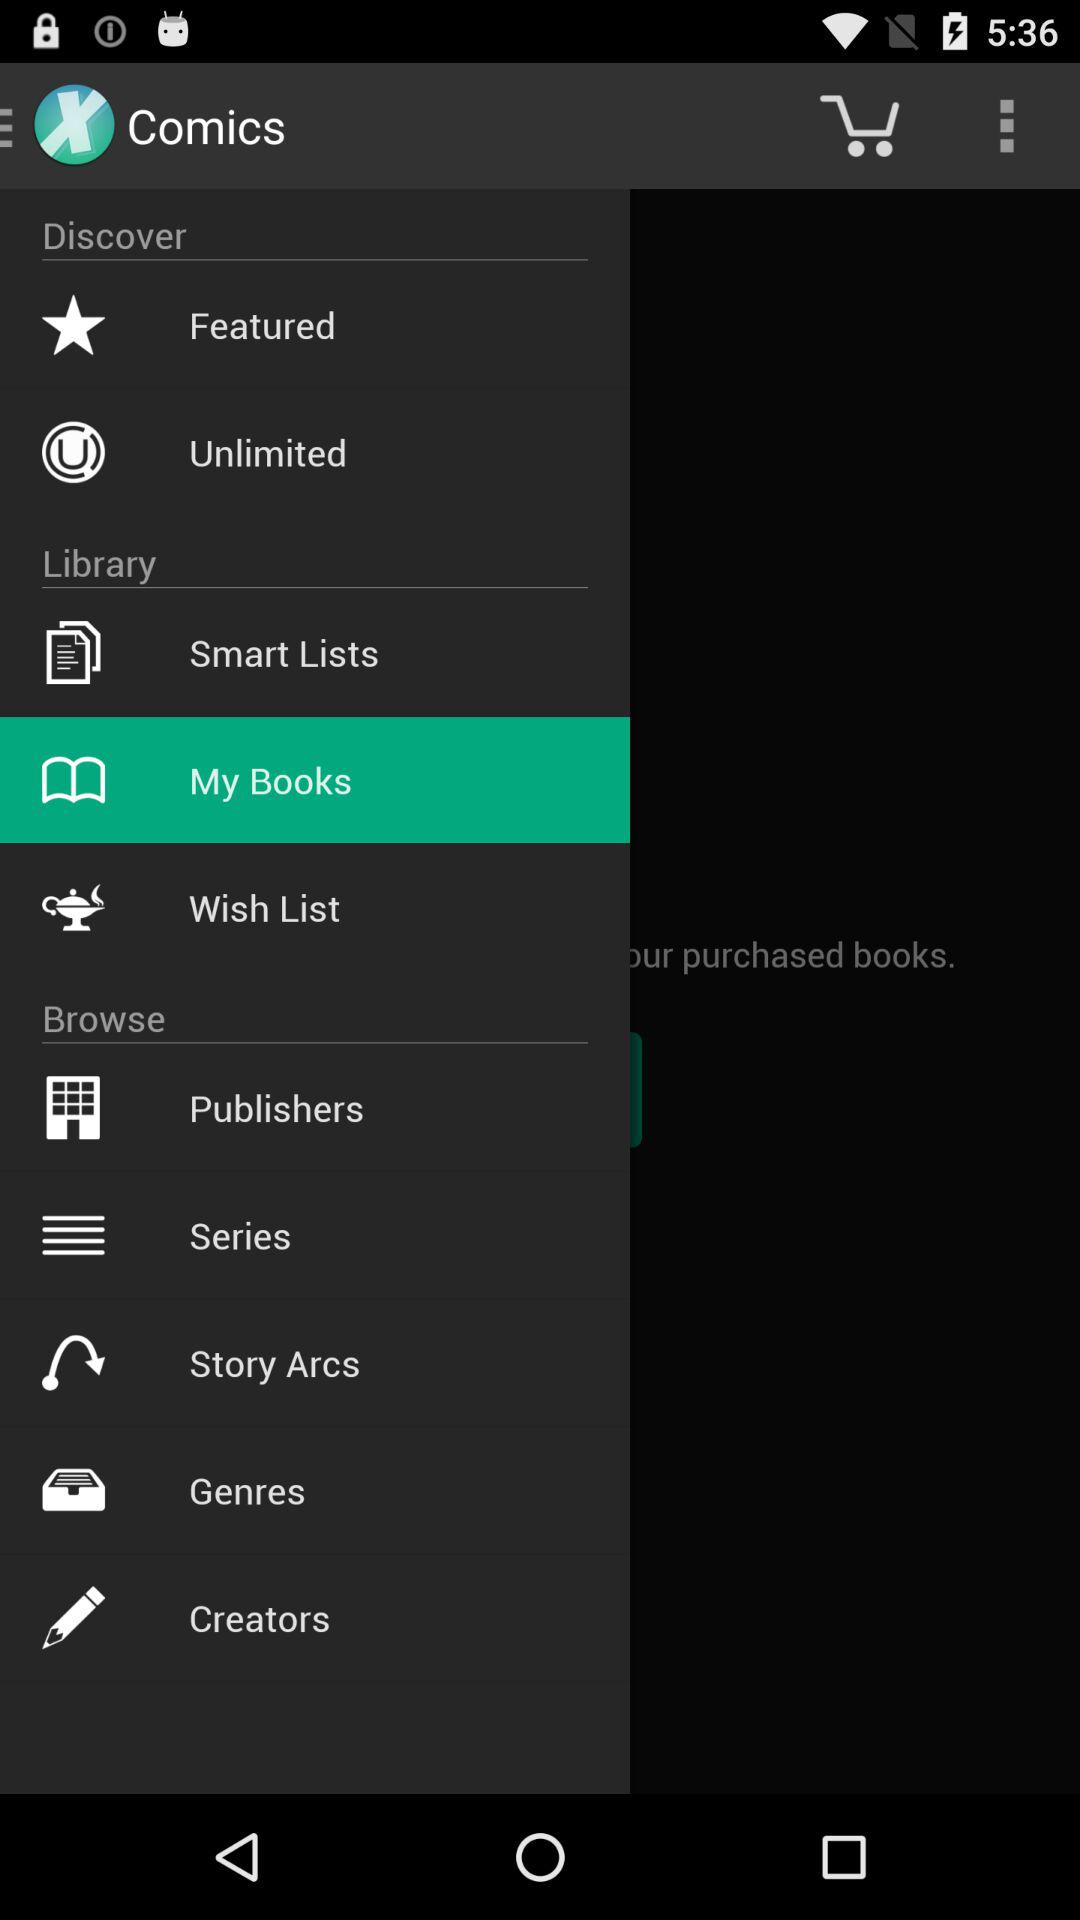What is the selected item? The selected item is "My Books". 